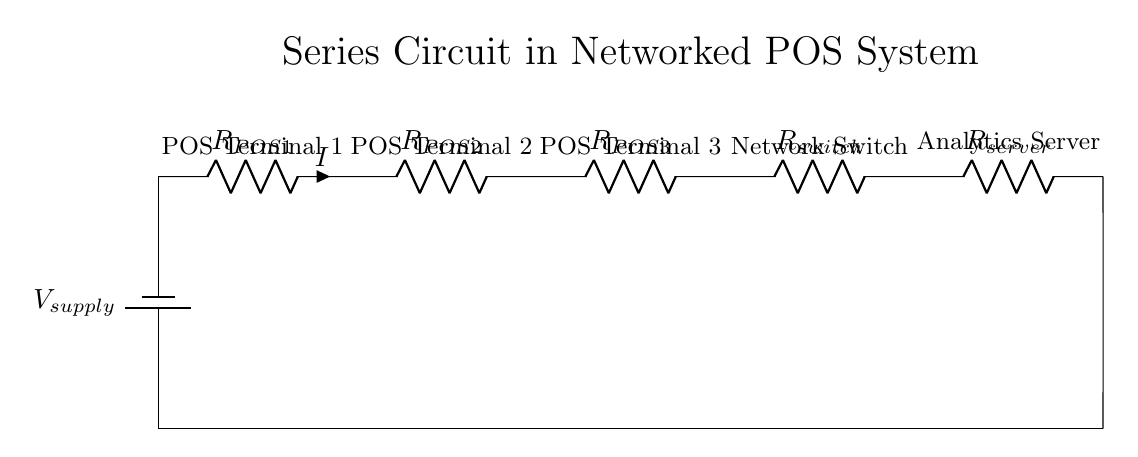What is the total number of resistors in the circuit? There are five resistors in the circuit: three for the point-of-sale terminals, one for the network switch, and one for the server connectivity.
Answer: five What component connects POS terminals to the analytics server? The network switch connects the POS terminals to the analytics server in this series circuit.
Answer: network switch What is the current in the circuit labeled as? The current flowing through the circuit is labeled as "I". This indicates that the same current flows through all components in a series circuit.
Answer: I If one POS terminal fails, what happens to the rest? If one POS terminal fails, it will cause the entire circuit to not function because components in a series circuit must all be operational for current to flow.
Answer: entire circuit fails What is the characteristic behavior of voltage in a series circuit? In a series circuit, the total voltage supplied by the battery is divided among the resistors, based on their resistance values. Each resistor experiences a voltage drop proportional to its resistance.
Answer: divided What is the role of the battery in the circuit? The battery provides the source voltage for the entire circuit, supplying the necessary electrical energy for the components to operate.
Answer: source voltage How does resistance affect current flow in this circuit? As this is a series circuit, the total resistance increases with the addition of each resistor, leading to a decrease in current flow according to Ohm's law if the supply voltage remains constant.
Answer: decreases 